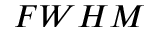<formula> <loc_0><loc_0><loc_500><loc_500>F W H M</formula> 